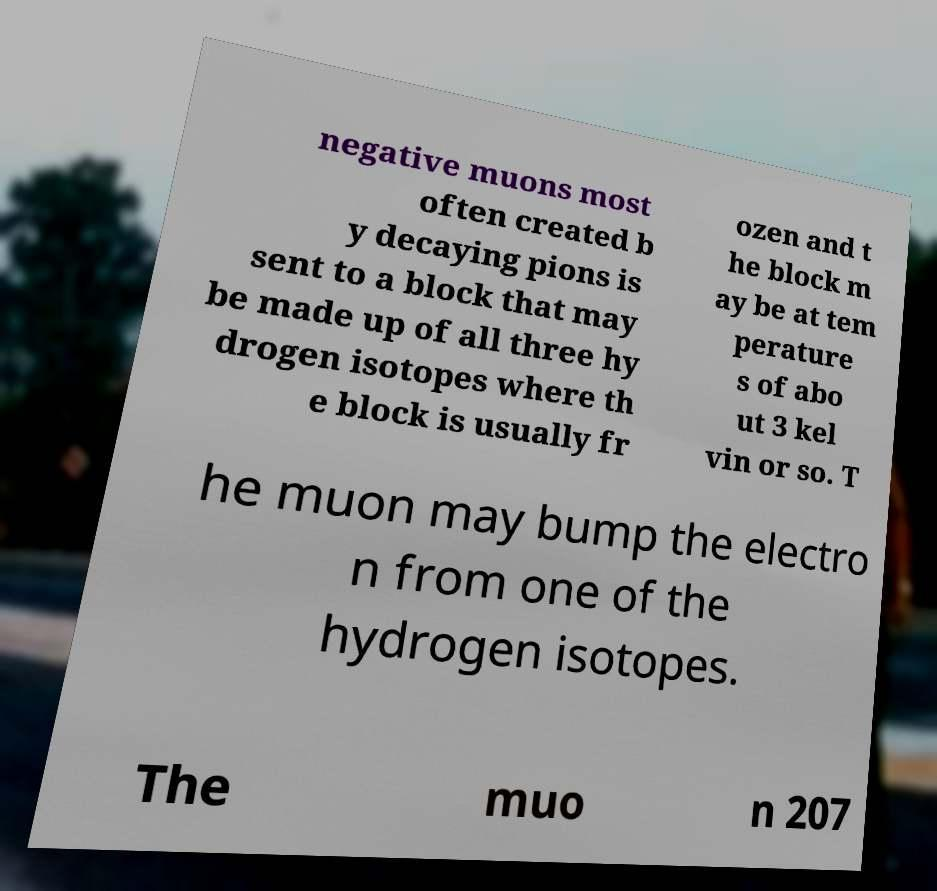Can you accurately transcribe the text from the provided image for me? negative muons most often created b y decaying pions is sent to a block that may be made up of all three hy drogen isotopes where th e block is usually fr ozen and t he block m ay be at tem perature s of abo ut 3 kel vin or so. T he muon may bump the electro n from one of the hydrogen isotopes. The muo n 207 